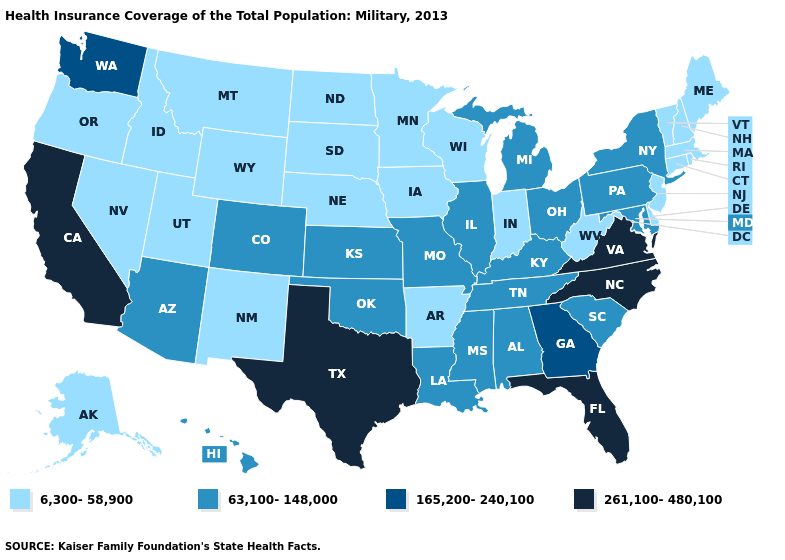Does the first symbol in the legend represent the smallest category?
Concise answer only. Yes. Among the states that border Massachusetts , which have the lowest value?
Write a very short answer. Connecticut, New Hampshire, Rhode Island, Vermont. Which states hav the highest value in the Northeast?
Be succinct. New York, Pennsylvania. What is the lowest value in the South?
Write a very short answer. 6,300-58,900. Which states have the lowest value in the USA?
Give a very brief answer. Alaska, Arkansas, Connecticut, Delaware, Idaho, Indiana, Iowa, Maine, Massachusetts, Minnesota, Montana, Nebraska, Nevada, New Hampshire, New Jersey, New Mexico, North Dakota, Oregon, Rhode Island, South Dakota, Utah, Vermont, West Virginia, Wisconsin, Wyoming. Among the states that border Ohio , does Michigan have the lowest value?
Be succinct. No. Does the map have missing data?
Concise answer only. No. Name the states that have a value in the range 6,300-58,900?
Keep it brief. Alaska, Arkansas, Connecticut, Delaware, Idaho, Indiana, Iowa, Maine, Massachusetts, Minnesota, Montana, Nebraska, Nevada, New Hampshire, New Jersey, New Mexico, North Dakota, Oregon, Rhode Island, South Dakota, Utah, Vermont, West Virginia, Wisconsin, Wyoming. Which states hav the highest value in the West?
Keep it brief. California. Name the states that have a value in the range 261,100-480,100?
Answer briefly. California, Florida, North Carolina, Texas, Virginia. What is the value of Georgia?
Short answer required. 165,200-240,100. What is the value of Montana?
Concise answer only. 6,300-58,900. How many symbols are there in the legend?
Short answer required. 4. What is the value of Arkansas?
Write a very short answer. 6,300-58,900. Which states have the lowest value in the USA?
Keep it brief. Alaska, Arkansas, Connecticut, Delaware, Idaho, Indiana, Iowa, Maine, Massachusetts, Minnesota, Montana, Nebraska, Nevada, New Hampshire, New Jersey, New Mexico, North Dakota, Oregon, Rhode Island, South Dakota, Utah, Vermont, West Virginia, Wisconsin, Wyoming. 